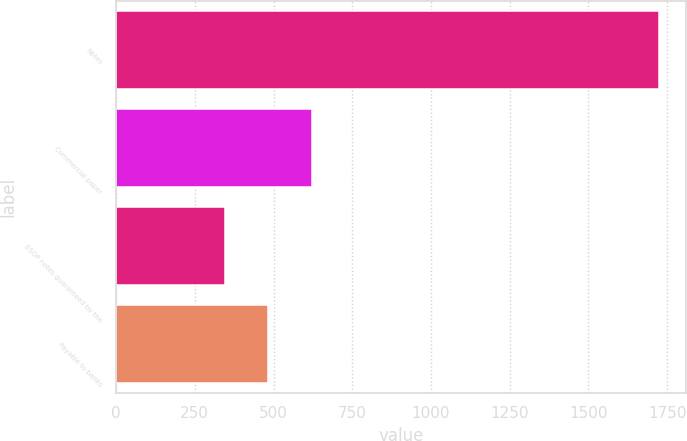Convert chart to OTSL. <chart><loc_0><loc_0><loc_500><loc_500><bar_chart><fcel>Notes<fcel>Commercial paper<fcel>ESOP notes guaranteed by the<fcel>Payable to banks<nl><fcel>1724.7<fcel>621.1<fcel>345.2<fcel>483.15<nl></chart> 